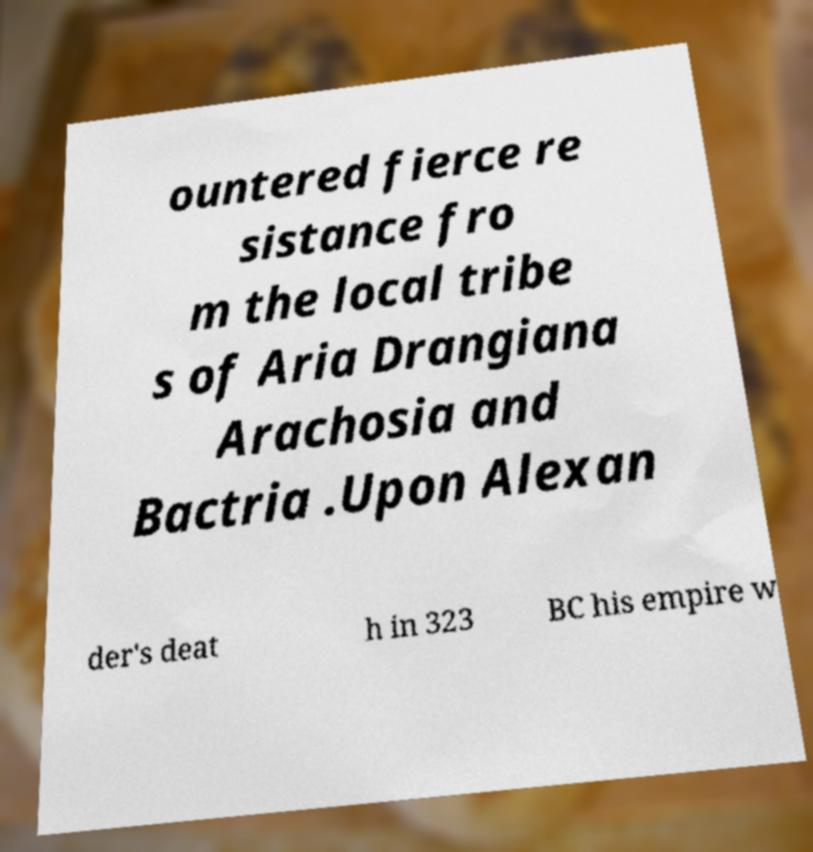Please identify and transcribe the text found in this image. ountered fierce re sistance fro m the local tribe s of Aria Drangiana Arachosia and Bactria .Upon Alexan der's deat h in 323 BC his empire w 